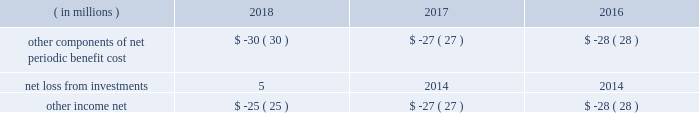52 s&p global 2018 annual report cash consideration that would be received for instances when the service components are sold separately .
If the fair value to the customer for each service is not objectively determinable , we make our best estimate of the services 2019 stand-alone selling price and record revenue as it is earned over the service period .
Receivables we record a receivable when a customer is billed or when revenue is recognized prior to billing a customer .
For multi- year agreements , we generally invoice customers annually at the beginning of each annual period .
The opening balance of accounts receivable , net of allowance for doubtful accounts , was $ 1319 million as of january 1 , 2018 .
Contract assets contract assets include unbilled amounts from when the company transfers service to a customer before a customer pays consideration or before payment is due .
As of december 31 , 2018 and 2017 , contract assets were $ 26 million and $ 17 million , respectively , and are included in accounts receivable in our consolidated balance sheets .
Unearned revenue we record unearned revenue when cash payments are received or due in advance of our performance .
The increase in the unearned revenue balance for the year ended december 31 , 2018 is primarily driven by cash payments received or due in advance of satisfying our performance obligations , offset by $ 1.5 billion of revenues recognized that were included in the unearned revenue balance at the beginning of the period .
Remaining performance obligations remaining performance obligations represent the transaction price of contracts for work that has not yet been performed .
As of december 31 , 2018 , the aggregate amount of the transaction price allocated to remaining performance obligations was $ 1.4 billion .
We expect to recognize revenue on approximately half and three-quarters of the remaining performance obligations over the next 12 and 24 months , respectively , with the remainder recognized thereafter .
We do not disclose the value of unfulfilled performance obligations for ( i ) contracts with an original expected length of one year or less and ( ii ) contracts where revenue is a usage-based royalty promised in exchange for a license of intellectual property .
Costs to obtain a contract we recognize an asset for the incremental costs of obtaining a contract with a customer if we expect the benefit of those costs to be longer than one year .
We have determined that certain sales commission programs meet the requirements to be capitalized .
Total capitalized costs to obtain a contract were $ 101 million as of december 31 , 2018 , and are included in prepaid and other current assets and other non-current assets on our consolidated balance sheets .
The asset will be amortized over a period consistent with the transfer to the customer of the goods or services to which the asset relates , calculated based on the customer term and the average life of the products and services underlying the contracts .
The expense is recorded within selling and general expenses .
We expense sales commissions when incurred if the amortization period would have been one year or less .
These costs are recorded within selling and general expenses .
Presentation of net periodic pension cost and net periodic postretirement benefit cost during the first quarter of 2018 , we adopted new accounting guidance requiring that net periodic benefit cost for our retirement and postretirement plans other than the service cost component be included outside of operating profit ; these costs are included in other income , net in our consolidated statements of income .
The components of other income , net for the year ended december 31 are as follows : assets and liabilities held for sale and discontinued operations assets and liabilities held for sale we classify a disposal group to be sold as held for sale in the period in which all of the following criteria are met : management , having the authority to approve the action , commits to a plan to sell the disposal group ; the disposal group is available for immediate sale in its present condition subject only to terms that are usual and customary for sales of such disposal group ; an active program to locate a buyer and other actions required to complete the plan to sell the disposal group have been initiated ; the sale of the disposal group is probable , and transfer of the disposal group is expected to qualify for recognition as a completed sale within one year , except if events or circumstances beyond our control extend the period of time required to sell the disposal group beyond one year ; the disposal group is being actively marketed for sale at a price that is reasonable in relation to its current fair value ; and actions required to complete the plan indicate that it is unlikely that significant changes to the plan will be made or that the plan will be withdrawn .
A disposal group that is classified as held for sale is initially measured at the lower of its carrying value or fair value less any costs to sell .
Any loss resulting from this measurement is recognized in the period in which the held for sale criteria are met .
Conversely , gains are not recognized on the sale of a disposal group until the date of sale .
( in millions ) 2018 2017 2016 other components of net periodic benefit cost $ ( 30 ) $ ( 27 ) $ ( 28 ) .

What was the decline in the other net income from 2016 to 2018? 
Rationale: the other net income declined by 10.7% from 2016 to 2018
Computations: ((25 - 28) / 28)
Answer: -0.10714. 